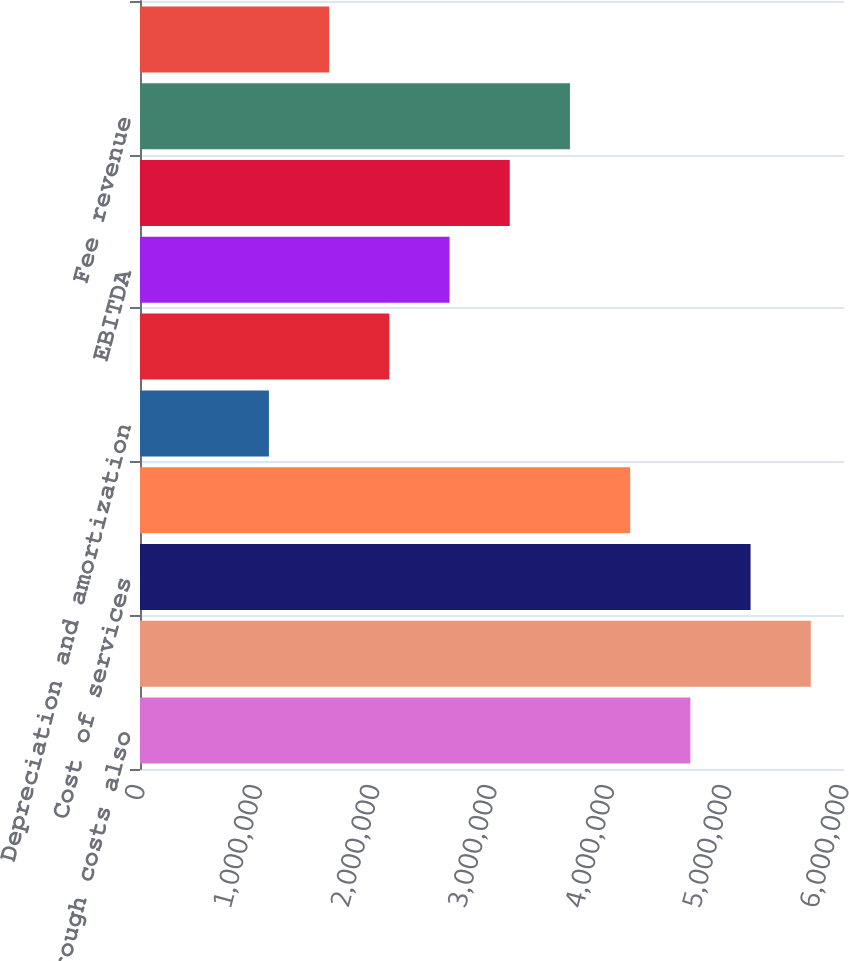Convert chart. <chart><loc_0><loc_0><loc_500><loc_500><bar_chart><fcel>Pass through costs also<fcel>Total revenue<fcel>Cost of services<fcel>Operating administrative and<fcel>Depreciation and amortization<fcel>Operating income<fcel>EBITDA<fcel>Adjusted EBITDA<fcel>Fee revenue<fcel>Revenue<nl><fcel>4.69063e+06<fcel>5.7169e+06<fcel>5.20377e+06<fcel>4.17749e+06<fcel>1.09866e+06<fcel>2.12494e+06<fcel>2.63808e+06<fcel>3.15121e+06<fcel>3.66435e+06<fcel>1.6118e+06<nl></chart> 